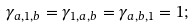<formula> <loc_0><loc_0><loc_500><loc_500>\gamma _ { a , 1 , b } = \gamma _ { 1 , a , b } = \gamma _ { a , b , 1 } = 1 ;</formula> 